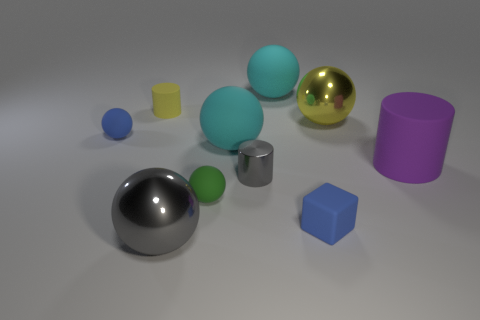Subtract all big purple rubber cylinders. How many cylinders are left? 2 Subtract all green blocks. How many cyan spheres are left? 2 Subtract all yellow balls. How many balls are left? 5 Subtract all cylinders. How many objects are left? 7 Subtract 2 spheres. How many spheres are left? 4 Subtract 0 purple balls. How many objects are left? 10 Subtract all red balls. Subtract all green cylinders. How many balls are left? 6 Subtract all big blue rubber cubes. Subtract all green spheres. How many objects are left? 9 Add 3 small yellow objects. How many small yellow objects are left? 4 Add 2 small blue rubber spheres. How many small blue rubber spheres exist? 3 